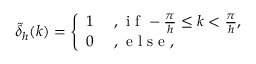Convert formula to latex. <formula><loc_0><loc_0><loc_500><loc_500>\tilde { \delta } _ { h } ( k ) = \left \{ \begin{array} { l l } { 1 } & { , i f - \frac { \pi } { h } \leq k < \frac { \pi } { h } , } \\ { 0 } & { , e l s e , } \end{array}</formula> 